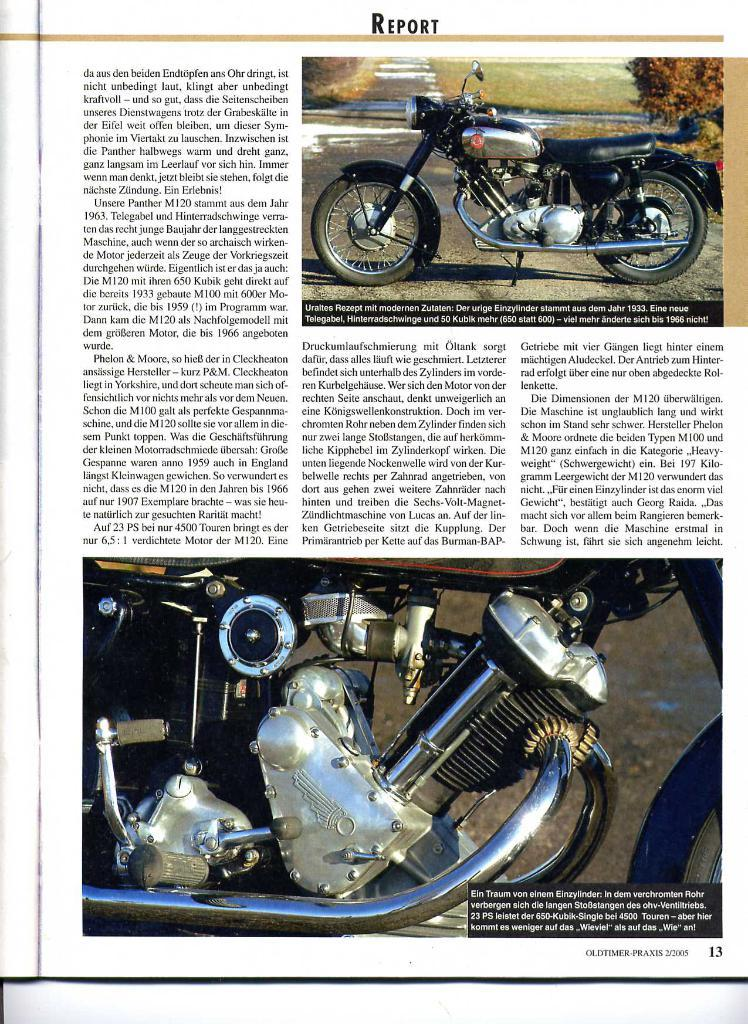What is the primary object in the image? There is a white paper in the image. What is on the white paper? Something is written on the paper. What else can be seen in the image besides the white paper? There is a photo of a motorcycle in the image, and the engine of a motorcycle is visible. Where is the veil located in the image? There is no veil present in the image. What type of camp can be seen in the background of the image? There is no camp present in the image. 